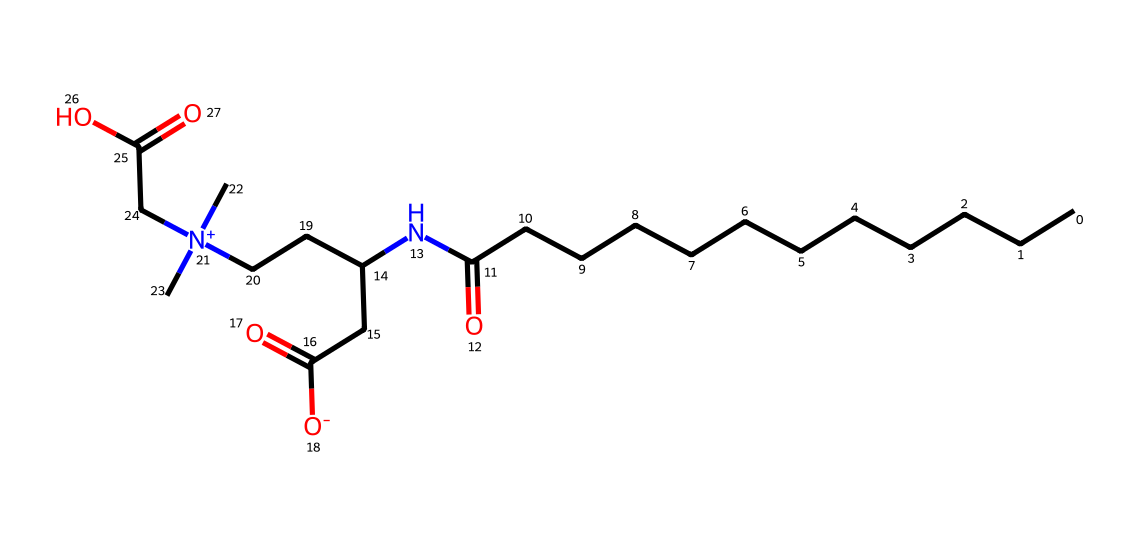What is the main functional group present in cocamidopropyl betaine? The chemical structure shows the presence of a quaternary ammonium group, which is indicated by the nitrogen atom connected to four carbon atoms and one oxygen atom.
Answer: quaternary ammonium How many carbon atoms are in cocamidopropyl betaine? By counting the carbon symbols (C) in the SMILES representation, we find there are 15 carbon atoms present in different functional groups throughout the molecule.
Answer: 15 What type of surfactant is cocamidopropyl betaine classified as? The presence of both hydrophobic (long carbon chain) and hydrophilic (quaternary ammonium) parts indicates that this surfactant can function as both an amphoteric and mild surfactant.
Answer: amphoteric What is the charge on the nitrogen atom in cocamidopropyl betaine? Observing the nitrogen (N) connected to four groups in this molecular structure indicates that it carries a positive charge as suggested by the notation [N+].
Answer: positive How does the molecular structure of cocamidopropyl betaine contribute to its eco-friendliness? The structure showcases renewable sources, primarily derived from coconut oil, which aligns it towards being biodegradable and therefore more environmentally friendly compared to many synthetic detergents.
Answer: biodegradable 